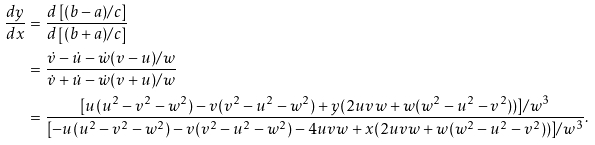Convert formula to latex. <formula><loc_0><loc_0><loc_500><loc_500>\frac { d y } { d x } & = \frac { d \left [ ( b - a ) / c \right ] } { d \left [ ( b + a ) / c \right ] } \\ & = \frac { \dot { v } - \dot { u } - \dot { w } ( v - u ) / w } { \dot { v } + \dot { u } - \dot { w } ( v + u ) / w } \\ & = \frac { [ u ( u ^ { 2 } - v ^ { 2 } - w ^ { 2 } ) - v ( v ^ { 2 } - u ^ { 2 } - w ^ { 2 } ) + y ( 2 u v w + w ( w ^ { 2 } - u ^ { 2 } - v ^ { 2 } ) ) ] / w ^ { 3 } } { [ - u ( u ^ { 2 } - v ^ { 2 } - w ^ { 2 } ) - v ( v ^ { 2 } - u ^ { 2 } - w ^ { 2 } ) - 4 u v w + x ( 2 u v w + w ( w ^ { 2 } - u ^ { 2 } - v ^ { 2 } ) ) ] / w ^ { 3 } } .</formula> 